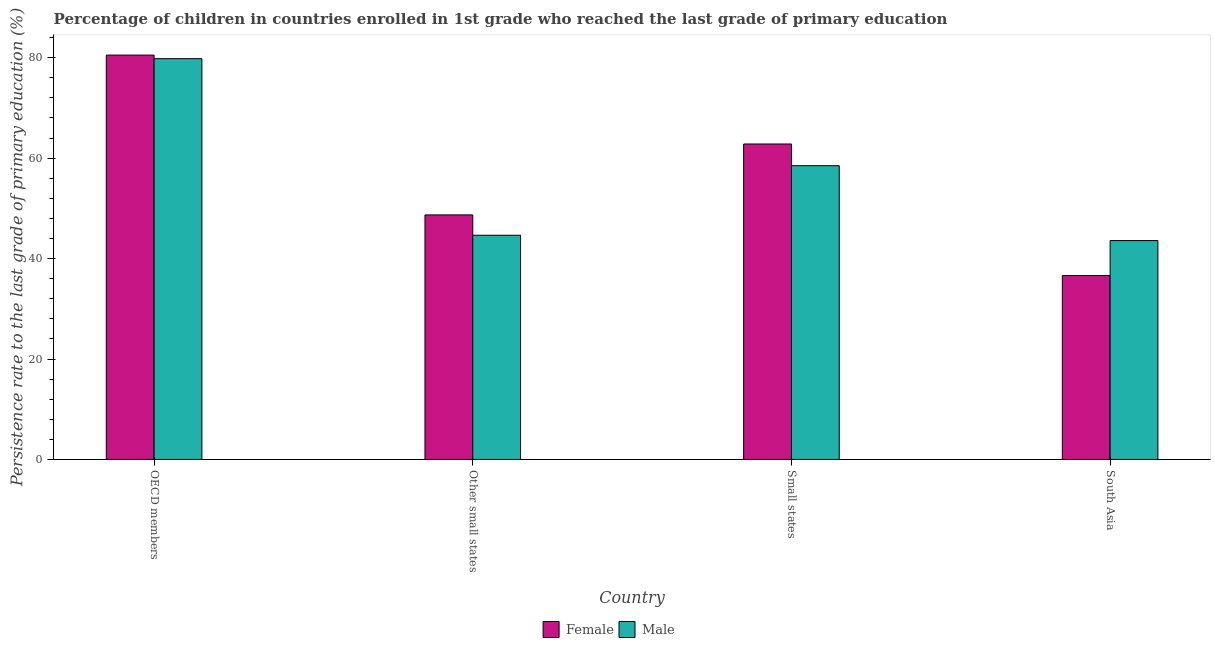Are the number of bars per tick equal to the number of legend labels?
Your answer should be very brief. Yes. How many bars are there on the 2nd tick from the left?
Offer a terse response. 2. What is the label of the 2nd group of bars from the left?
Provide a short and direct response. Other small states. In how many cases, is the number of bars for a given country not equal to the number of legend labels?
Give a very brief answer. 0. What is the persistence rate of male students in Small states?
Provide a short and direct response. 58.49. Across all countries, what is the maximum persistence rate of male students?
Give a very brief answer. 79.81. Across all countries, what is the minimum persistence rate of male students?
Your response must be concise. 43.58. What is the total persistence rate of male students in the graph?
Your answer should be very brief. 226.54. What is the difference between the persistence rate of male students in OECD members and that in South Asia?
Ensure brevity in your answer.  36.23. What is the difference between the persistence rate of male students in Small states and the persistence rate of female students in Other small states?
Your response must be concise. 9.8. What is the average persistence rate of male students per country?
Offer a terse response. 56.63. What is the difference between the persistence rate of male students and persistence rate of female students in OECD members?
Provide a short and direct response. -0.71. In how many countries, is the persistence rate of female students greater than 68 %?
Provide a succinct answer. 1. What is the ratio of the persistence rate of male students in Small states to that in South Asia?
Your answer should be very brief. 1.34. Is the persistence rate of male students in Other small states less than that in Small states?
Offer a terse response. Yes. What is the difference between the highest and the second highest persistence rate of female students?
Make the answer very short. 17.7. What is the difference between the highest and the lowest persistence rate of female students?
Your response must be concise. 43.9. In how many countries, is the persistence rate of male students greater than the average persistence rate of male students taken over all countries?
Ensure brevity in your answer.  2. What does the 1st bar from the right in OECD members represents?
Keep it short and to the point. Male. How many bars are there?
Your response must be concise. 8. How many countries are there in the graph?
Make the answer very short. 4. What is the difference between two consecutive major ticks on the Y-axis?
Ensure brevity in your answer.  20. Are the values on the major ticks of Y-axis written in scientific E-notation?
Offer a very short reply. No. Does the graph contain any zero values?
Provide a short and direct response. No. How many legend labels are there?
Offer a terse response. 2. How are the legend labels stacked?
Provide a short and direct response. Horizontal. What is the title of the graph?
Offer a very short reply. Percentage of children in countries enrolled in 1st grade who reached the last grade of primary education. Does "Ages 15-24" appear as one of the legend labels in the graph?
Offer a very short reply. No. What is the label or title of the Y-axis?
Make the answer very short. Persistence rate to the last grade of primary education (%). What is the Persistence rate to the last grade of primary education (%) of Female in OECD members?
Keep it short and to the point. 80.52. What is the Persistence rate to the last grade of primary education (%) of Male in OECD members?
Offer a terse response. 79.81. What is the Persistence rate to the last grade of primary education (%) of Female in Other small states?
Provide a short and direct response. 48.7. What is the Persistence rate to the last grade of primary education (%) in Male in Other small states?
Keep it short and to the point. 44.65. What is the Persistence rate to the last grade of primary education (%) in Female in Small states?
Offer a very short reply. 62.82. What is the Persistence rate to the last grade of primary education (%) in Male in Small states?
Keep it short and to the point. 58.49. What is the Persistence rate to the last grade of primary education (%) in Female in South Asia?
Make the answer very short. 36.62. What is the Persistence rate to the last grade of primary education (%) in Male in South Asia?
Give a very brief answer. 43.58. Across all countries, what is the maximum Persistence rate to the last grade of primary education (%) in Female?
Ensure brevity in your answer.  80.52. Across all countries, what is the maximum Persistence rate to the last grade of primary education (%) in Male?
Provide a succinct answer. 79.81. Across all countries, what is the minimum Persistence rate to the last grade of primary education (%) of Female?
Your answer should be compact. 36.62. Across all countries, what is the minimum Persistence rate to the last grade of primary education (%) of Male?
Offer a very short reply. 43.58. What is the total Persistence rate to the last grade of primary education (%) in Female in the graph?
Keep it short and to the point. 228.66. What is the total Persistence rate to the last grade of primary education (%) of Male in the graph?
Your answer should be very brief. 226.54. What is the difference between the Persistence rate to the last grade of primary education (%) of Female in OECD members and that in Other small states?
Your answer should be compact. 31.83. What is the difference between the Persistence rate to the last grade of primary education (%) in Male in OECD members and that in Other small states?
Make the answer very short. 35.17. What is the difference between the Persistence rate to the last grade of primary education (%) in Female in OECD members and that in Small states?
Your answer should be compact. 17.7. What is the difference between the Persistence rate to the last grade of primary education (%) in Male in OECD members and that in Small states?
Keep it short and to the point. 21.32. What is the difference between the Persistence rate to the last grade of primary education (%) of Female in OECD members and that in South Asia?
Provide a short and direct response. 43.9. What is the difference between the Persistence rate to the last grade of primary education (%) in Male in OECD members and that in South Asia?
Ensure brevity in your answer.  36.23. What is the difference between the Persistence rate to the last grade of primary education (%) in Female in Other small states and that in Small states?
Your response must be concise. -14.12. What is the difference between the Persistence rate to the last grade of primary education (%) of Male in Other small states and that in Small states?
Keep it short and to the point. -13.85. What is the difference between the Persistence rate to the last grade of primary education (%) of Female in Other small states and that in South Asia?
Your response must be concise. 12.07. What is the difference between the Persistence rate to the last grade of primary education (%) in Male in Other small states and that in South Asia?
Ensure brevity in your answer.  1.06. What is the difference between the Persistence rate to the last grade of primary education (%) of Female in Small states and that in South Asia?
Ensure brevity in your answer.  26.2. What is the difference between the Persistence rate to the last grade of primary education (%) in Male in Small states and that in South Asia?
Make the answer very short. 14.91. What is the difference between the Persistence rate to the last grade of primary education (%) in Female in OECD members and the Persistence rate to the last grade of primary education (%) in Male in Other small states?
Give a very brief answer. 35.88. What is the difference between the Persistence rate to the last grade of primary education (%) of Female in OECD members and the Persistence rate to the last grade of primary education (%) of Male in Small states?
Give a very brief answer. 22.03. What is the difference between the Persistence rate to the last grade of primary education (%) in Female in OECD members and the Persistence rate to the last grade of primary education (%) in Male in South Asia?
Provide a succinct answer. 36.94. What is the difference between the Persistence rate to the last grade of primary education (%) of Female in Other small states and the Persistence rate to the last grade of primary education (%) of Male in Small states?
Give a very brief answer. -9.8. What is the difference between the Persistence rate to the last grade of primary education (%) of Female in Other small states and the Persistence rate to the last grade of primary education (%) of Male in South Asia?
Your answer should be compact. 5.11. What is the difference between the Persistence rate to the last grade of primary education (%) in Female in Small states and the Persistence rate to the last grade of primary education (%) in Male in South Asia?
Your response must be concise. 19.24. What is the average Persistence rate to the last grade of primary education (%) of Female per country?
Your response must be concise. 57.17. What is the average Persistence rate to the last grade of primary education (%) in Male per country?
Provide a short and direct response. 56.63. What is the difference between the Persistence rate to the last grade of primary education (%) in Female and Persistence rate to the last grade of primary education (%) in Male in OECD members?
Provide a short and direct response. 0.71. What is the difference between the Persistence rate to the last grade of primary education (%) of Female and Persistence rate to the last grade of primary education (%) of Male in Other small states?
Provide a succinct answer. 4.05. What is the difference between the Persistence rate to the last grade of primary education (%) in Female and Persistence rate to the last grade of primary education (%) in Male in Small states?
Provide a succinct answer. 4.33. What is the difference between the Persistence rate to the last grade of primary education (%) of Female and Persistence rate to the last grade of primary education (%) of Male in South Asia?
Your response must be concise. -6.96. What is the ratio of the Persistence rate to the last grade of primary education (%) in Female in OECD members to that in Other small states?
Provide a succinct answer. 1.65. What is the ratio of the Persistence rate to the last grade of primary education (%) of Male in OECD members to that in Other small states?
Give a very brief answer. 1.79. What is the ratio of the Persistence rate to the last grade of primary education (%) in Female in OECD members to that in Small states?
Provide a short and direct response. 1.28. What is the ratio of the Persistence rate to the last grade of primary education (%) in Male in OECD members to that in Small states?
Keep it short and to the point. 1.36. What is the ratio of the Persistence rate to the last grade of primary education (%) in Female in OECD members to that in South Asia?
Offer a very short reply. 2.2. What is the ratio of the Persistence rate to the last grade of primary education (%) of Male in OECD members to that in South Asia?
Your answer should be compact. 1.83. What is the ratio of the Persistence rate to the last grade of primary education (%) in Female in Other small states to that in Small states?
Your answer should be very brief. 0.78. What is the ratio of the Persistence rate to the last grade of primary education (%) of Male in Other small states to that in Small states?
Your answer should be very brief. 0.76. What is the ratio of the Persistence rate to the last grade of primary education (%) in Female in Other small states to that in South Asia?
Provide a succinct answer. 1.33. What is the ratio of the Persistence rate to the last grade of primary education (%) in Male in Other small states to that in South Asia?
Your response must be concise. 1.02. What is the ratio of the Persistence rate to the last grade of primary education (%) in Female in Small states to that in South Asia?
Give a very brief answer. 1.72. What is the ratio of the Persistence rate to the last grade of primary education (%) in Male in Small states to that in South Asia?
Your response must be concise. 1.34. What is the difference between the highest and the second highest Persistence rate to the last grade of primary education (%) in Female?
Your response must be concise. 17.7. What is the difference between the highest and the second highest Persistence rate to the last grade of primary education (%) of Male?
Offer a very short reply. 21.32. What is the difference between the highest and the lowest Persistence rate to the last grade of primary education (%) of Female?
Give a very brief answer. 43.9. What is the difference between the highest and the lowest Persistence rate to the last grade of primary education (%) of Male?
Offer a very short reply. 36.23. 